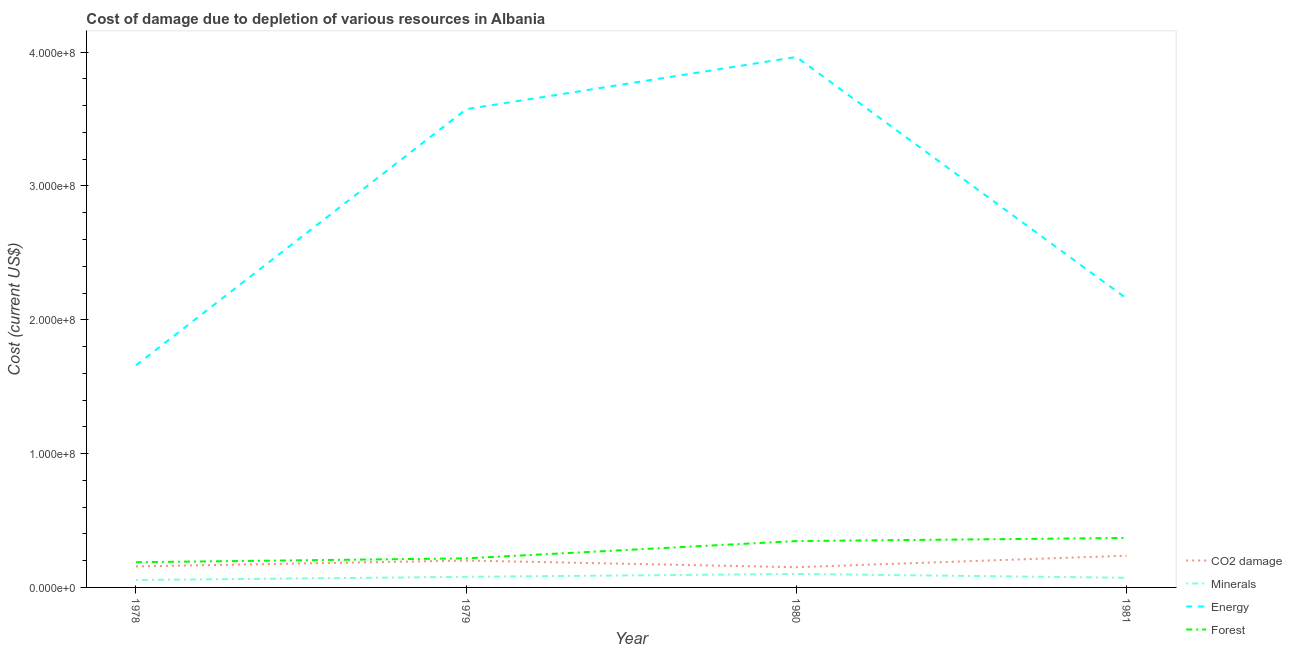Does the line corresponding to cost of damage due to depletion of forests intersect with the line corresponding to cost of damage due to depletion of coal?
Your response must be concise. No. Is the number of lines equal to the number of legend labels?
Your answer should be very brief. Yes. What is the cost of damage due to depletion of minerals in 1978?
Give a very brief answer. 5.53e+06. Across all years, what is the maximum cost of damage due to depletion of energy?
Ensure brevity in your answer.  3.96e+08. Across all years, what is the minimum cost of damage due to depletion of energy?
Make the answer very short. 1.66e+08. In which year was the cost of damage due to depletion of energy minimum?
Keep it short and to the point. 1978. What is the total cost of damage due to depletion of coal in the graph?
Offer a terse response. 7.46e+07. What is the difference between the cost of damage due to depletion of coal in 1979 and that in 1981?
Make the answer very short. -3.63e+06. What is the difference between the cost of damage due to depletion of energy in 1978 and the cost of damage due to depletion of coal in 1980?
Make the answer very short. 1.51e+08. What is the average cost of damage due to depletion of forests per year?
Keep it short and to the point. 2.80e+07. In the year 1978, what is the difference between the cost of damage due to depletion of energy and cost of damage due to depletion of coal?
Offer a terse response. 1.50e+08. In how many years, is the cost of damage due to depletion of coal greater than 320000000 US$?
Provide a succinct answer. 0. What is the ratio of the cost of damage due to depletion of forests in 1980 to that in 1981?
Your response must be concise. 0.94. Is the cost of damage due to depletion of energy in 1978 less than that in 1981?
Offer a very short reply. Yes. What is the difference between the highest and the second highest cost of damage due to depletion of minerals?
Offer a terse response. 2.16e+06. What is the difference between the highest and the lowest cost of damage due to depletion of minerals?
Offer a very short reply. 4.54e+06. Is the sum of the cost of damage due to depletion of energy in 1979 and 1980 greater than the maximum cost of damage due to depletion of minerals across all years?
Keep it short and to the point. Yes. Does the cost of damage due to depletion of minerals monotonically increase over the years?
Your response must be concise. No. Is the cost of damage due to depletion of coal strictly greater than the cost of damage due to depletion of minerals over the years?
Offer a very short reply. Yes. What is the difference between two consecutive major ticks on the Y-axis?
Ensure brevity in your answer.  1.00e+08. Are the values on the major ticks of Y-axis written in scientific E-notation?
Provide a succinct answer. Yes. Does the graph contain any zero values?
Offer a very short reply. No. Does the graph contain grids?
Your response must be concise. No. How are the legend labels stacked?
Offer a terse response. Vertical. What is the title of the graph?
Provide a succinct answer. Cost of damage due to depletion of various resources in Albania . Does "Forest" appear as one of the legend labels in the graph?
Give a very brief answer. Yes. What is the label or title of the X-axis?
Ensure brevity in your answer.  Year. What is the label or title of the Y-axis?
Give a very brief answer. Cost (current US$). What is the Cost (current US$) of CO2 damage in 1978?
Provide a succinct answer. 1.57e+07. What is the Cost (current US$) in Minerals in 1978?
Provide a short and direct response. 5.53e+06. What is the Cost (current US$) of Energy in 1978?
Ensure brevity in your answer.  1.66e+08. What is the Cost (current US$) of Forest in 1978?
Provide a succinct answer. 1.88e+07. What is the Cost (current US$) in CO2 damage in 1979?
Your response must be concise. 2.01e+07. What is the Cost (current US$) in Minerals in 1979?
Your answer should be compact. 7.91e+06. What is the Cost (current US$) in Energy in 1979?
Ensure brevity in your answer.  3.57e+08. What is the Cost (current US$) in Forest in 1979?
Give a very brief answer. 2.17e+07. What is the Cost (current US$) in CO2 damage in 1980?
Make the answer very short. 1.51e+07. What is the Cost (current US$) of Minerals in 1980?
Give a very brief answer. 1.01e+07. What is the Cost (current US$) of Energy in 1980?
Provide a succinct answer. 3.96e+08. What is the Cost (current US$) of Forest in 1980?
Keep it short and to the point. 3.47e+07. What is the Cost (current US$) of CO2 damage in 1981?
Make the answer very short. 2.37e+07. What is the Cost (current US$) in Minerals in 1981?
Make the answer very short. 7.21e+06. What is the Cost (current US$) in Energy in 1981?
Your answer should be compact. 2.16e+08. What is the Cost (current US$) of Forest in 1981?
Provide a short and direct response. 3.70e+07. Across all years, what is the maximum Cost (current US$) of CO2 damage?
Ensure brevity in your answer.  2.37e+07. Across all years, what is the maximum Cost (current US$) of Minerals?
Your answer should be compact. 1.01e+07. Across all years, what is the maximum Cost (current US$) of Energy?
Your answer should be very brief. 3.96e+08. Across all years, what is the maximum Cost (current US$) of Forest?
Make the answer very short. 3.70e+07. Across all years, what is the minimum Cost (current US$) of CO2 damage?
Offer a very short reply. 1.51e+07. Across all years, what is the minimum Cost (current US$) of Minerals?
Offer a terse response. 5.53e+06. Across all years, what is the minimum Cost (current US$) of Energy?
Ensure brevity in your answer.  1.66e+08. Across all years, what is the minimum Cost (current US$) in Forest?
Your answer should be compact. 1.88e+07. What is the total Cost (current US$) in CO2 damage in the graph?
Offer a terse response. 7.46e+07. What is the total Cost (current US$) in Minerals in the graph?
Your answer should be compact. 3.07e+07. What is the total Cost (current US$) in Energy in the graph?
Your response must be concise. 1.14e+09. What is the total Cost (current US$) in Forest in the graph?
Offer a very short reply. 1.12e+08. What is the difference between the Cost (current US$) of CO2 damage in 1978 and that in 1979?
Your answer should be compact. -4.39e+06. What is the difference between the Cost (current US$) of Minerals in 1978 and that in 1979?
Give a very brief answer. -2.39e+06. What is the difference between the Cost (current US$) of Energy in 1978 and that in 1979?
Offer a very short reply. -1.91e+08. What is the difference between the Cost (current US$) in Forest in 1978 and that in 1979?
Your answer should be compact. -2.88e+06. What is the difference between the Cost (current US$) in CO2 damage in 1978 and that in 1980?
Your answer should be compact. 5.99e+05. What is the difference between the Cost (current US$) of Minerals in 1978 and that in 1980?
Ensure brevity in your answer.  -4.54e+06. What is the difference between the Cost (current US$) of Energy in 1978 and that in 1980?
Provide a short and direct response. -2.30e+08. What is the difference between the Cost (current US$) in Forest in 1978 and that in 1980?
Your answer should be compact. -1.58e+07. What is the difference between the Cost (current US$) in CO2 damage in 1978 and that in 1981?
Your response must be concise. -8.02e+06. What is the difference between the Cost (current US$) of Minerals in 1978 and that in 1981?
Offer a very short reply. -1.69e+06. What is the difference between the Cost (current US$) in Energy in 1978 and that in 1981?
Provide a short and direct response. -4.99e+07. What is the difference between the Cost (current US$) of Forest in 1978 and that in 1981?
Keep it short and to the point. -1.81e+07. What is the difference between the Cost (current US$) of CO2 damage in 1979 and that in 1980?
Ensure brevity in your answer.  4.99e+06. What is the difference between the Cost (current US$) in Minerals in 1979 and that in 1980?
Your answer should be very brief. -2.16e+06. What is the difference between the Cost (current US$) of Energy in 1979 and that in 1980?
Your answer should be compact. -3.90e+07. What is the difference between the Cost (current US$) of Forest in 1979 and that in 1980?
Offer a very short reply. -1.29e+07. What is the difference between the Cost (current US$) of CO2 damage in 1979 and that in 1981?
Offer a very short reply. -3.63e+06. What is the difference between the Cost (current US$) in Minerals in 1979 and that in 1981?
Your answer should be compact. 7.00e+05. What is the difference between the Cost (current US$) in Energy in 1979 and that in 1981?
Your answer should be very brief. 1.42e+08. What is the difference between the Cost (current US$) of Forest in 1979 and that in 1981?
Your response must be concise. -1.52e+07. What is the difference between the Cost (current US$) of CO2 damage in 1980 and that in 1981?
Keep it short and to the point. -8.62e+06. What is the difference between the Cost (current US$) of Minerals in 1980 and that in 1981?
Keep it short and to the point. 2.86e+06. What is the difference between the Cost (current US$) in Energy in 1980 and that in 1981?
Provide a succinct answer. 1.81e+08. What is the difference between the Cost (current US$) in Forest in 1980 and that in 1981?
Give a very brief answer. -2.31e+06. What is the difference between the Cost (current US$) in CO2 damage in 1978 and the Cost (current US$) in Minerals in 1979?
Give a very brief answer. 7.80e+06. What is the difference between the Cost (current US$) of CO2 damage in 1978 and the Cost (current US$) of Energy in 1979?
Your answer should be very brief. -3.42e+08. What is the difference between the Cost (current US$) in CO2 damage in 1978 and the Cost (current US$) in Forest in 1979?
Make the answer very short. -6.01e+06. What is the difference between the Cost (current US$) of Minerals in 1978 and the Cost (current US$) of Energy in 1979?
Give a very brief answer. -3.52e+08. What is the difference between the Cost (current US$) in Minerals in 1978 and the Cost (current US$) in Forest in 1979?
Your response must be concise. -1.62e+07. What is the difference between the Cost (current US$) in Energy in 1978 and the Cost (current US$) in Forest in 1979?
Keep it short and to the point. 1.44e+08. What is the difference between the Cost (current US$) of CO2 damage in 1978 and the Cost (current US$) of Minerals in 1980?
Ensure brevity in your answer.  5.64e+06. What is the difference between the Cost (current US$) of CO2 damage in 1978 and the Cost (current US$) of Energy in 1980?
Provide a short and direct response. -3.81e+08. What is the difference between the Cost (current US$) in CO2 damage in 1978 and the Cost (current US$) in Forest in 1980?
Offer a very short reply. -1.89e+07. What is the difference between the Cost (current US$) in Minerals in 1978 and the Cost (current US$) in Energy in 1980?
Your response must be concise. -3.91e+08. What is the difference between the Cost (current US$) of Minerals in 1978 and the Cost (current US$) of Forest in 1980?
Keep it short and to the point. -2.91e+07. What is the difference between the Cost (current US$) in Energy in 1978 and the Cost (current US$) in Forest in 1980?
Offer a terse response. 1.31e+08. What is the difference between the Cost (current US$) of CO2 damage in 1978 and the Cost (current US$) of Minerals in 1981?
Keep it short and to the point. 8.50e+06. What is the difference between the Cost (current US$) in CO2 damage in 1978 and the Cost (current US$) in Energy in 1981?
Offer a terse response. -2.00e+08. What is the difference between the Cost (current US$) of CO2 damage in 1978 and the Cost (current US$) of Forest in 1981?
Keep it short and to the point. -2.13e+07. What is the difference between the Cost (current US$) in Minerals in 1978 and the Cost (current US$) in Energy in 1981?
Provide a short and direct response. -2.10e+08. What is the difference between the Cost (current US$) in Minerals in 1978 and the Cost (current US$) in Forest in 1981?
Provide a short and direct response. -3.14e+07. What is the difference between the Cost (current US$) of Energy in 1978 and the Cost (current US$) of Forest in 1981?
Offer a very short reply. 1.29e+08. What is the difference between the Cost (current US$) in CO2 damage in 1979 and the Cost (current US$) in Minerals in 1980?
Give a very brief answer. 1.00e+07. What is the difference between the Cost (current US$) of CO2 damage in 1979 and the Cost (current US$) of Energy in 1980?
Offer a very short reply. -3.76e+08. What is the difference between the Cost (current US$) in CO2 damage in 1979 and the Cost (current US$) in Forest in 1980?
Provide a short and direct response. -1.46e+07. What is the difference between the Cost (current US$) in Minerals in 1979 and the Cost (current US$) in Energy in 1980?
Give a very brief answer. -3.89e+08. What is the difference between the Cost (current US$) in Minerals in 1979 and the Cost (current US$) in Forest in 1980?
Your answer should be compact. -2.67e+07. What is the difference between the Cost (current US$) in Energy in 1979 and the Cost (current US$) in Forest in 1980?
Offer a terse response. 3.23e+08. What is the difference between the Cost (current US$) of CO2 damage in 1979 and the Cost (current US$) of Minerals in 1981?
Offer a very short reply. 1.29e+07. What is the difference between the Cost (current US$) in CO2 damage in 1979 and the Cost (current US$) in Energy in 1981?
Offer a very short reply. -1.96e+08. What is the difference between the Cost (current US$) of CO2 damage in 1979 and the Cost (current US$) of Forest in 1981?
Give a very brief answer. -1.69e+07. What is the difference between the Cost (current US$) in Minerals in 1979 and the Cost (current US$) in Energy in 1981?
Your answer should be very brief. -2.08e+08. What is the difference between the Cost (current US$) in Minerals in 1979 and the Cost (current US$) in Forest in 1981?
Ensure brevity in your answer.  -2.90e+07. What is the difference between the Cost (current US$) in Energy in 1979 and the Cost (current US$) in Forest in 1981?
Provide a succinct answer. 3.20e+08. What is the difference between the Cost (current US$) of CO2 damage in 1980 and the Cost (current US$) of Minerals in 1981?
Your response must be concise. 7.90e+06. What is the difference between the Cost (current US$) in CO2 damage in 1980 and the Cost (current US$) in Energy in 1981?
Make the answer very short. -2.01e+08. What is the difference between the Cost (current US$) of CO2 damage in 1980 and the Cost (current US$) of Forest in 1981?
Make the answer very short. -2.19e+07. What is the difference between the Cost (current US$) in Minerals in 1980 and the Cost (current US$) in Energy in 1981?
Provide a short and direct response. -2.06e+08. What is the difference between the Cost (current US$) of Minerals in 1980 and the Cost (current US$) of Forest in 1981?
Your response must be concise. -2.69e+07. What is the difference between the Cost (current US$) in Energy in 1980 and the Cost (current US$) in Forest in 1981?
Offer a very short reply. 3.59e+08. What is the average Cost (current US$) of CO2 damage per year?
Ensure brevity in your answer.  1.87e+07. What is the average Cost (current US$) in Minerals per year?
Your answer should be very brief. 7.68e+06. What is the average Cost (current US$) in Energy per year?
Keep it short and to the point. 2.84e+08. What is the average Cost (current US$) in Forest per year?
Offer a terse response. 2.80e+07. In the year 1978, what is the difference between the Cost (current US$) in CO2 damage and Cost (current US$) in Minerals?
Your response must be concise. 1.02e+07. In the year 1978, what is the difference between the Cost (current US$) of CO2 damage and Cost (current US$) of Energy?
Give a very brief answer. -1.50e+08. In the year 1978, what is the difference between the Cost (current US$) of CO2 damage and Cost (current US$) of Forest?
Provide a succinct answer. -3.13e+06. In the year 1978, what is the difference between the Cost (current US$) of Minerals and Cost (current US$) of Energy?
Ensure brevity in your answer.  -1.60e+08. In the year 1978, what is the difference between the Cost (current US$) in Minerals and Cost (current US$) in Forest?
Offer a very short reply. -1.33e+07. In the year 1978, what is the difference between the Cost (current US$) in Energy and Cost (current US$) in Forest?
Keep it short and to the point. 1.47e+08. In the year 1979, what is the difference between the Cost (current US$) of CO2 damage and Cost (current US$) of Minerals?
Your answer should be compact. 1.22e+07. In the year 1979, what is the difference between the Cost (current US$) of CO2 damage and Cost (current US$) of Energy?
Provide a short and direct response. -3.37e+08. In the year 1979, what is the difference between the Cost (current US$) of CO2 damage and Cost (current US$) of Forest?
Make the answer very short. -1.62e+06. In the year 1979, what is the difference between the Cost (current US$) in Minerals and Cost (current US$) in Energy?
Ensure brevity in your answer.  -3.49e+08. In the year 1979, what is the difference between the Cost (current US$) of Minerals and Cost (current US$) of Forest?
Give a very brief answer. -1.38e+07. In the year 1979, what is the difference between the Cost (current US$) in Energy and Cost (current US$) in Forest?
Your answer should be compact. 3.36e+08. In the year 1980, what is the difference between the Cost (current US$) of CO2 damage and Cost (current US$) of Minerals?
Your answer should be very brief. 5.04e+06. In the year 1980, what is the difference between the Cost (current US$) of CO2 damage and Cost (current US$) of Energy?
Your response must be concise. -3.81e+08. In the year 1980, what is the difference between the Cost (current US$) in CO2 damage and Cost (current US$) in Forest?
Offer a terse response. -1.95e+07. In the year 1980, what is the difference between the Cost (current US$) in Minerals and Cost (current US$) in Energy?
Give a very brief answer. -3.86e+08. In the year 1980, what is the difference between the Cost (current US$) in Minerals and Cost (current US$) in Forest?
Provide a succinct answer. -2.46e+07. In the year 1980, what is the difference between the Cost (current US$) in Energy and Cost (current US$) in Forest?
Your response must be concise. 3.62e+08. In the year 1981, what is the difference between the Cost (current US$) of CO2 damage and Cost (current US$) of Minerals?
Offer a terse response. 1.65e+07. In the year 1981, what is the difference between the Cost (current US$) of CO2 damage and Cost (current US$) of Energy?
Offer a very short reply. -1.92e+08. In the year 1981, what is the difference between the Cost (current US$) in CO2 damage and Cost (current US$) in Forest?
Make the answer very short. -1.32e+07. In the year 1981, what is the difference between the Cost (current US$) in Minerals and Cost (current US$) in Energy?
Your response must be concise. -2.09e+08. In the year 1981, what is the difference between the Cost (current US$) of Minerals and Cost (current US$) of Forest?
Provide a short and direct response. -2.97e+07. In the year 1981, what is the difference between the Cost (current US$) of Energy and Cost (current US$) of Forest?
Make the answer very short. 1.79e+08. What is the ratio of the Cost (current US$) of CO2 damage in 1978 to that in 1979?
Offer a very short reply. 0.78. What is the ratio of the Cost (current US$) of Minerals in 1978 to that in 1979?
Offer a very short reply. 0.7. What is the ratio of the Cost (current US$) in Energy in 1978 to that in 1979?
Your answer should be very brief. 0.46. What is the ratio of the Cost (current US$) in Forest in 1978 to that in 1979?
Your response must be concise. 0.87. What is the ratio of the Cost (current US$) of CO2 damage in 1978 to that in 1980?
Provide a succinct answer. 1.04. What is the ratio of the Cost (current US$) in Minerals in 1978 to that in 1980?
Your answer should be compact. 0.55. What is the ratio of the Cost (current US$) of Energy in 1978 to that in 1980?
Offer a very short reply. 0.42. What is the ratio of the Cost (current US$) of Forest in 1978 to that in 1980?
Your answer should be compact. 0.54. What is the ratio of the Cost (current US$) in CO2 damage in 1978 to that in 1981?
Provide a succinct answer. 0.66. What is the ratio of the Cost (current US$) in Minerals in 1978 to that in 1981?
Offer a terse response. 0.77. What is the ratio of the Cost (current US$) of Energy in 1978 to that in 1981?
Give a very brief answer. 0.77. What is the ratio of the Cost (current US$) in Forest in 1978 to that in 1981?
Offer a terse response. 0.51. What is the ratio of the Cost (current US$) of CO2 damage in 1979 to that in 1980?
Provide a short and direct response. 1.33. What is the ratio of the Cost (current US$) of Minerals in 1979 to that in 1980?
Offer a terse response. 0.79. What is the ratio of the Cost (current US$) of Energy in 1979 to that in 1980?
Offer a very short reply. 0.9. What is the ratio of the Cost (current US$) of Forest in 1979 to that in 1980?
Your answer should be very brief. 0.63. What is the ratio of the Cost (current US$) of CO2 damage in 1979 to that in 1981?
Provide a short and direct response. 0.85. What is the ratio of the Cost (current US$) of Minerals in 1979 to that in 1981?
Your answer should be very brief. 1.1. What is the ratio of the Cost (current US$) in Energy in 1979 to that in 1981?
Make the answer very short. 1.66. What is the ratio of the Cost (current US$) of Forest in 1979 to that in 1981?
Offer a terse response. 0.59. What is the ratio of the Cost (current US$) in CO2 damage in 1980 to that in 1981?
Offer a terse response. 0.64. What is the ratio of the Cost (current US$) in Minerals in 1980 to that in 1981?
Make the answer very short. 1.4. What is the ratio of the Cost (current US$) of Energy in 1980 to that in 1981?
Keep it short and to the point. 1.84. What is the difference between the highest and the second highest Cost (current US$) in CO2 damage?
Offer a very short reply. 3.63e+06. What is the difference between the highest and the second highest Cost (current US$) in Minerals?
Offer a very short reply. 2.16e+06. What is the difference between the highest and the second highest Cost (current US$) of Energy?
Provide a succinct answer. 3.90e+07. What is the difference between the highest and the second highest Cost (current US$) of Forest?
Make the answer very short. 2.31e+06. What is the difference between the highest and the lowest Cost (current US$) in CO2 damage?
Your answer should be compact. 8.62e+06. What is the difference between the highest and the lowest Cost (current US$) in Minerals?
Offer a terse response. 4.54e+06. What is the difference between the highest and the lowest Cost (current US$) in Energy?
Your answer should be compact. 2.30e+08. What is the difference between the highest and the lowest Cost (current US$) in Forest?
Your response must be concise. 1.81e+07. 